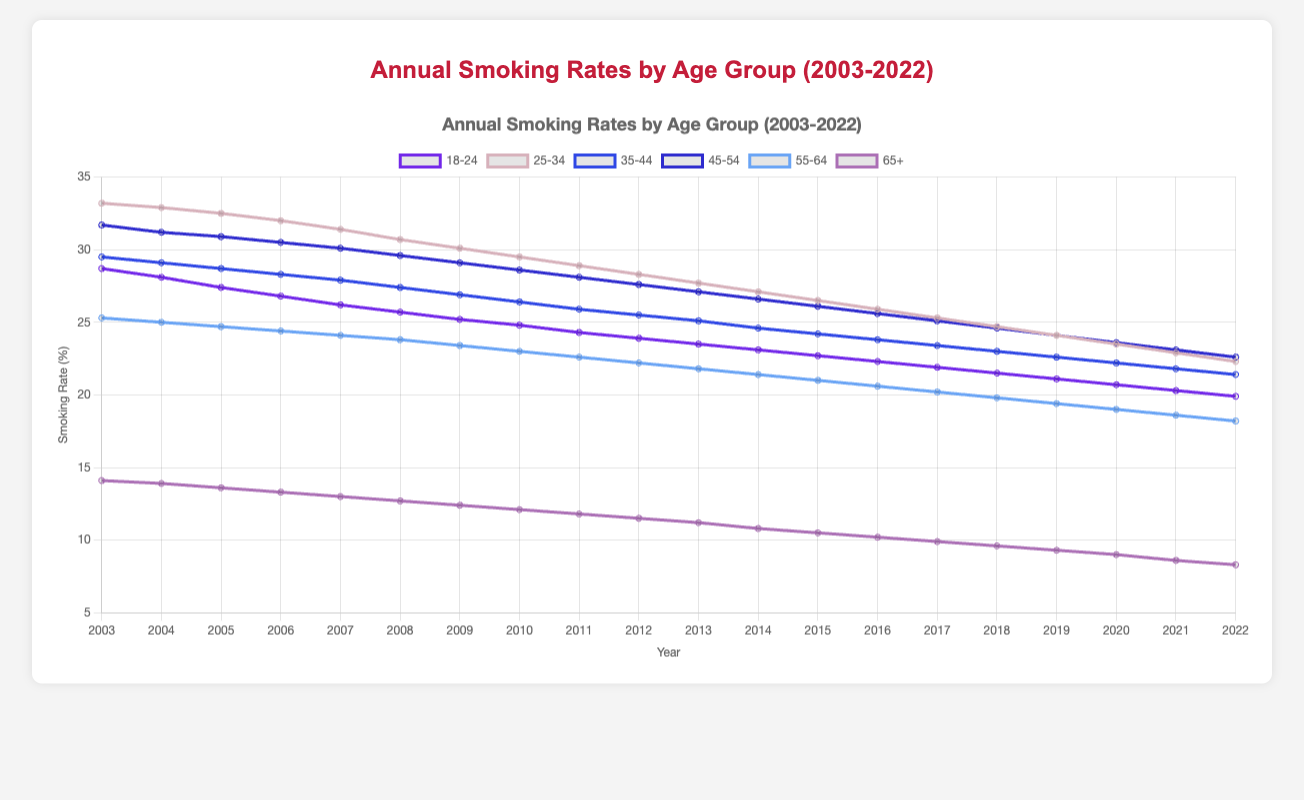Which age group had the highest smoking rate in 2003? By identifying the age group with the highest percentage in 2003, we see it's "25-34" with 33.2%.
Answer: 25-34 Which age group showed the most significant decrease in smoking rate from 2003 to 2022? Evaluating the decreases for all age groups: "18-24" decreased from 28.7% to 19.9% (8.8%), "25-34" from 33.2% to 22.3% (10.9%), "35-44" from 29.5% to 21.4% (8.1%), "45-54" from 31.7% to 22.6% (9.1%), "55-64" from 25.3% to 18.2% (7.1%), "65+" from 14.1% to 8.3% (5.8%). The age group "25-34" had the most significant decrease.
Answer: 25-34 By how much did the smoking rate for the age group 65+ decrease from 2003 to 2022? In 2003, the smoking rate for "65+" was 14.1%, and in 2022 it was 8.3%. The difference is 14.1% - 8.3% = 5.8%.
Answer: 5.8% Which age group had the least smoking rate in 2022? Looking at the percentages for 2022, "65+" had the lowest rate at 8.3%.
Answer: 65+ What is the average smoking rate for the age group 18-24 over the two decades? Summing up the rates for "18-24" from each year and dividing by the number of years: (28.7 + 28.1 + 27.4 + ... + 20.3 + 19.9) / 20. The total sum is 436.8, and 436.8 / 20 = 21.84.
Answer: 21.84 Which age group consistently showed a higher smoking rate: 35-44 or 55-64? Examining the rates for both groups over the years: "35-44" had consistently higher rates than "55-64" in each year.
Answer: 35-44 In which year did the smoking rate for the age group 18-24 first fall below 25%? By sequentially checking the rates for "18-24" each year, it first fell below 25% in 2010 (24.8%).
Answer: 2010 Which year had the smallest difference in smoking rates between the age groups 25-34 and 55-64? Calculating the difference for each year: in 2022, "25-34" was 22.3% and "55-64" was 18.2%, the difference is 4.1%, the smallest difference throughout the years.
Answer: 2022 What is the trend of smoking rates for the age group 45-54 from 2003 to 2022? Observing the plotted trend for "45-54" shows a general downward trend from 31.7% in 2003 to 22.6% in 2022.
Answer: Decreasing How did the smoking rate for 25-34 compare to 18-24 throughout the 20 years? By visual comparison, the smoking rate for "25-34" was consistently higher than "18-24" across all years from 2003 to 2022.
Answer: Higher 